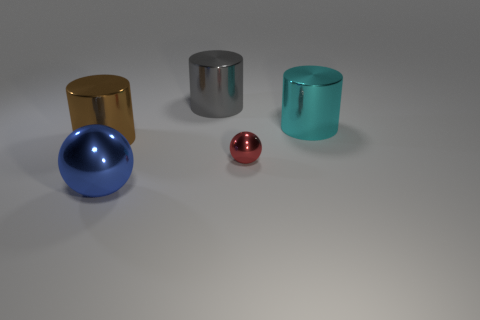The thing that is right of the gray metallic object and in front of the large brown shiny cylinder is made of what material?
Provide a short and direct response. Metal. Are there the same number of gray things behind the tiny red metal object and small purple rubber cylinders?
Provide a succinct answer. No. How many things are either shiny objects on the left side of the big blue ball or blue metal spheres?
Your response must be concise. 2. There is a cylinder in front of the large cyan shiny object; is it the same color as the big metal ball?
Ensure brevity in your answer.  No. How big is the metal sphere in front of the red metal ball?
Provide a short and direct response. Large. There is a large thing that is on the left side of the ball that is on the left side of the small object; what shape is it?
Your answer should be very brief. Cylinder. There is another object that is the same shape as the big blue thing; what is its color?
Keep it short and to the point. Red. There is a metal thing in front of the red ball; does it have the same size as the big gray metal cylinder?
Offer a terse response. Yes. How many tiny spheres have the same material as the large cyan thing?
Keep it short and to the point. 1. The big thing that is in front of the brown cylinder that is left of the large shiny thing right of the small metallic thing is made of what material?
Offer a very short reply. Metal. 